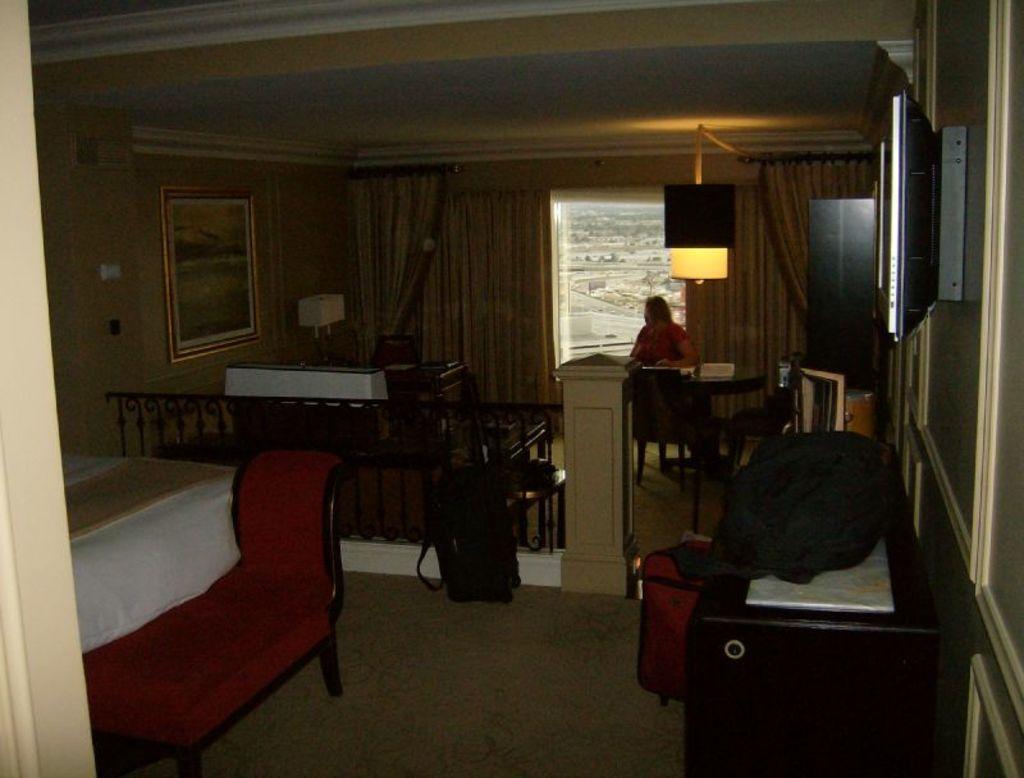Please provide a concise description of this image. In this image we can see a person sitting. In front of the person there are few objects on a table and a chair. In the foreground we can see a wooden railing, couch and a bed. On the right side, we can see few objects on a table and a wall. On the wall a television is attached. On the left side, we can see a pillar and a frame attached to the wall. Behind the person we can see the curtains and a window. Through the window we can see the ground and plants. 